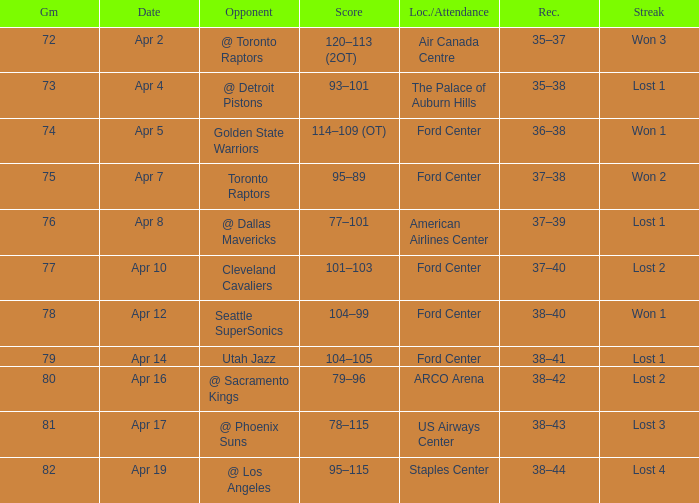What was the location when the opponent was Seattle Supersonics? Ford Center. 